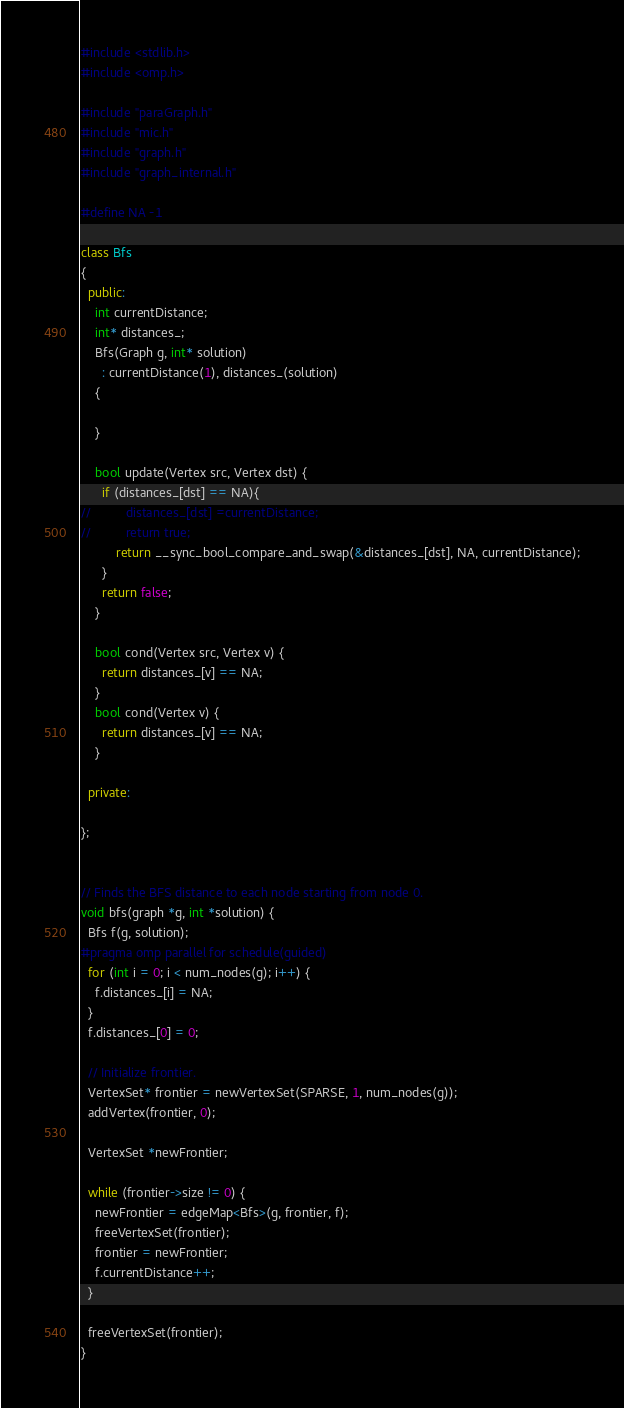Convert code to text. <code><loc_0><loc_0><loc_500><loc_500><_C++_>#include <stdlib.h>
#include <omp.h>

#include "paraGraph.h"
#include "mic.h"
#include "graph.h"
#include "graph_internal.h"

#define NA -1

class Bfs
{
  public:
    int currentDistance;
    int* distances_;
    Bfs(Graph g, int* solution)
      : currentDistance(1), distances_(solution)
    {

    }

    bool update(Vertex src, Vertex dst) {
      if (distances_[dst] == NA){
//          distances_[dst] =currentDistance;
//          return true;
          return __sync_bool_compare_and_swap(&distances_[dst], NA, currentDistance);
      }
      return false;
    }

    bool cond(Vertex src, Vertex v) {
      return distances_[v] == NA;
    }
    bool cond(Vertex v) {
      return distances_[v] == NA;
    }

  private:

};


// Finds the BFS distance to each node starting from node 0.
void bfs(graph *g, int *solution) {
  Bfs f(g, solution);
#pragma omp parallel for schedule(guided)
  for (int i = 0; i < num_nodes(g); i++) {
    f.distances_[i] = NA;
  }
  f.distances_[0] = 0;

  // Initialize frontier.
  VertexSet* frontier = newVertexSet(SPARSE, 1, num_nodes(g));
  addVertex(frontier, 0);

  VertexSet *newFrontier;

  while (frontier->size != 0) {
    newFrontier = edgeMap<Bfs>(g, frontier, f);
    freeVertexSet(frontier);
    frontier = newFrontier;
    f.currentDistance++;
  }

  freeVertexSet(frontier);
}
</code> 